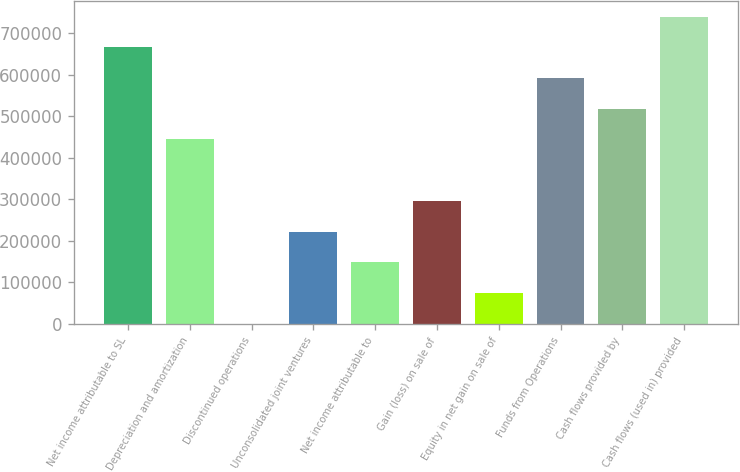Convert chart to OTSL. <chart><loc_0><loc_0><loc_500><loc_500><bar_chart><fcel>Net income attributable to SL<fcel>Depreciation and amortization<fcel>Discontinued operations<fcel>Unconsolidated joint ventures<fcel>Net income attributable to<fcel>Gain (loss) on sale of<fcel>Equity in net gain on sale of<fcel>Funds from Operations<fcel>Cash flows provided by<fcel>Cash flows (used in) provided<nl><fcel>665705<fcel>444029<fcel>676<fcel>222352<fcel>148460<fcel>296244<fcel>74568.1<fcel>591813<fcel>517921<fcel>739597<nl></chart> 